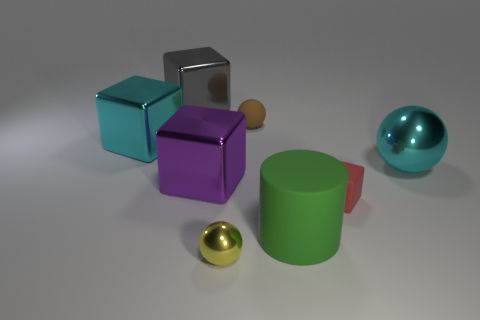Add 1 large shiny spheres. How many objects exist? 9 Subtract all spheres. How many objects are left? 5 Subtract 0 yellow blocks. How many objects are left? 8 Subtract all tiny cyan metallic cubes. Subtract all tiny brown rubber objects. How many objects are left? 7 Add 1 brown rubber things. How many brown rubber things are left? 2 Add 8 green matte things. How many green matte things exist? 9 